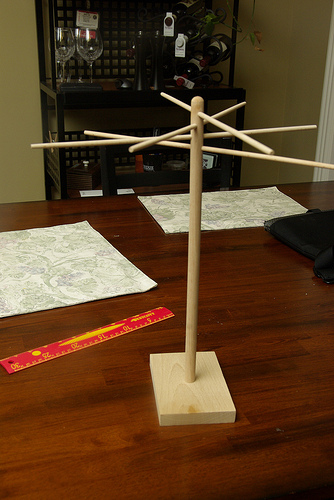<image>
Can you confirm if the metal is behind the ruler? Yes. From this viewpoint, the metal is positioned behind the ruler, with the ruler partially or fully occluding the metal. 